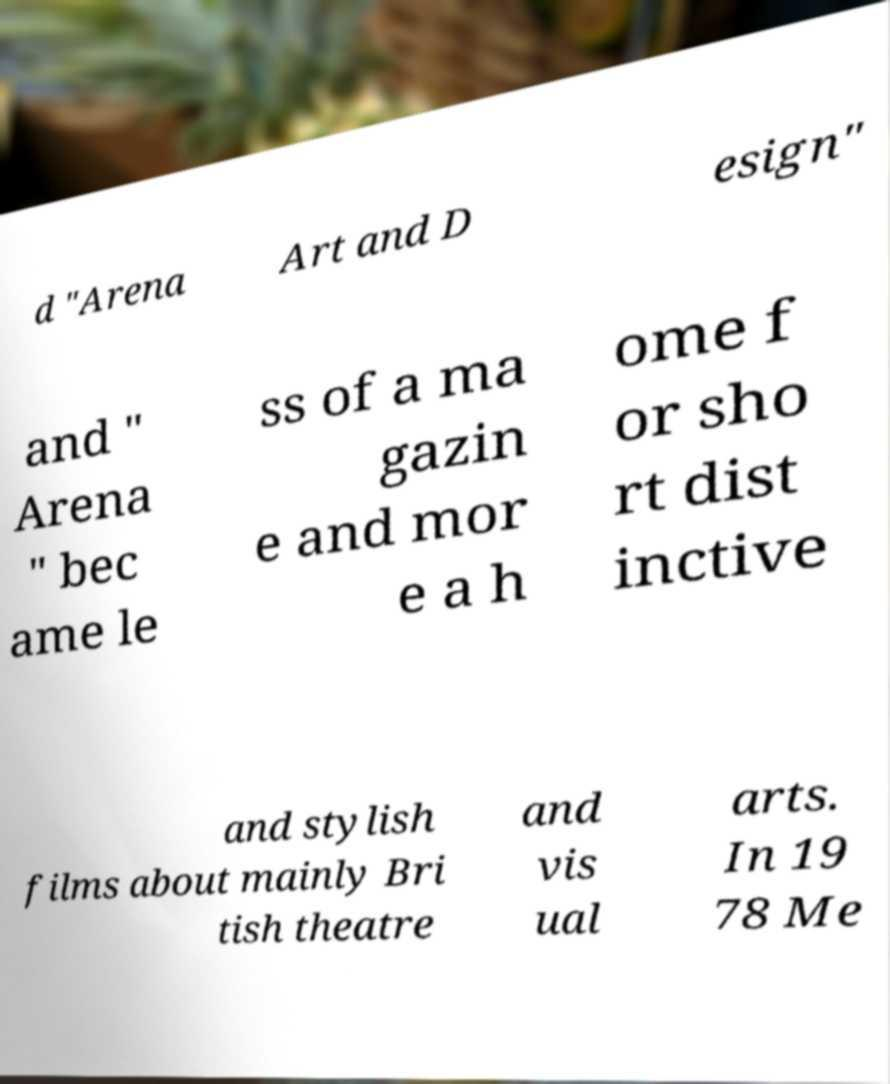There's text embedded in this image that I need extracted. Can you transcribe it verbatim? d "Arena Art and D esign" and " Arena " bec ame le ss of a ma gazin e and mor e a h ome f or sho rt dist inctive and stylish films about mainly Bri tish theatre and vis ual arts. In 19 78 Me 